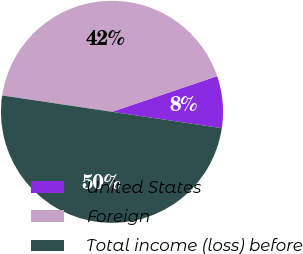Convert chart. <chart><loc_0><loc_0><loc_500><loc_500><pie_chart><fcel>United States<fcel>Foreign<fcel>Total income (loss) before<nl><fcel>7.56%<fcel>42.44%<fcel>50.0%<nl></chart> 